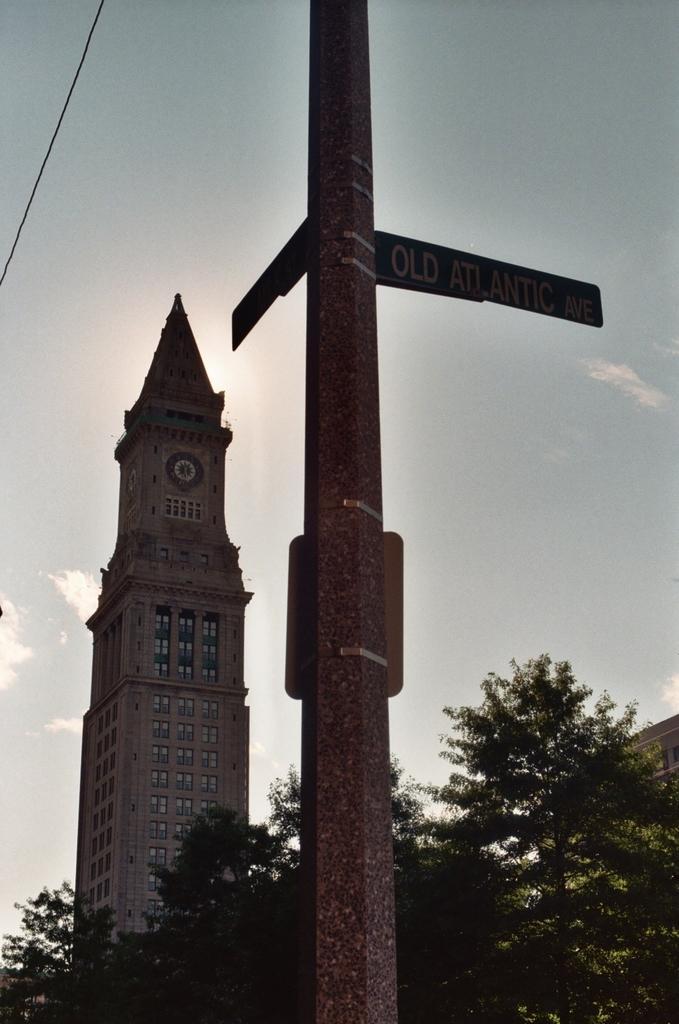How would you summarize this image in a sentence or two? This picture is clicked outside. In the center we can see the boards attached to the pole and we can see the trees and a spire and we can see a clock hanging on the spire. In the background we can see the sky and a cable. 